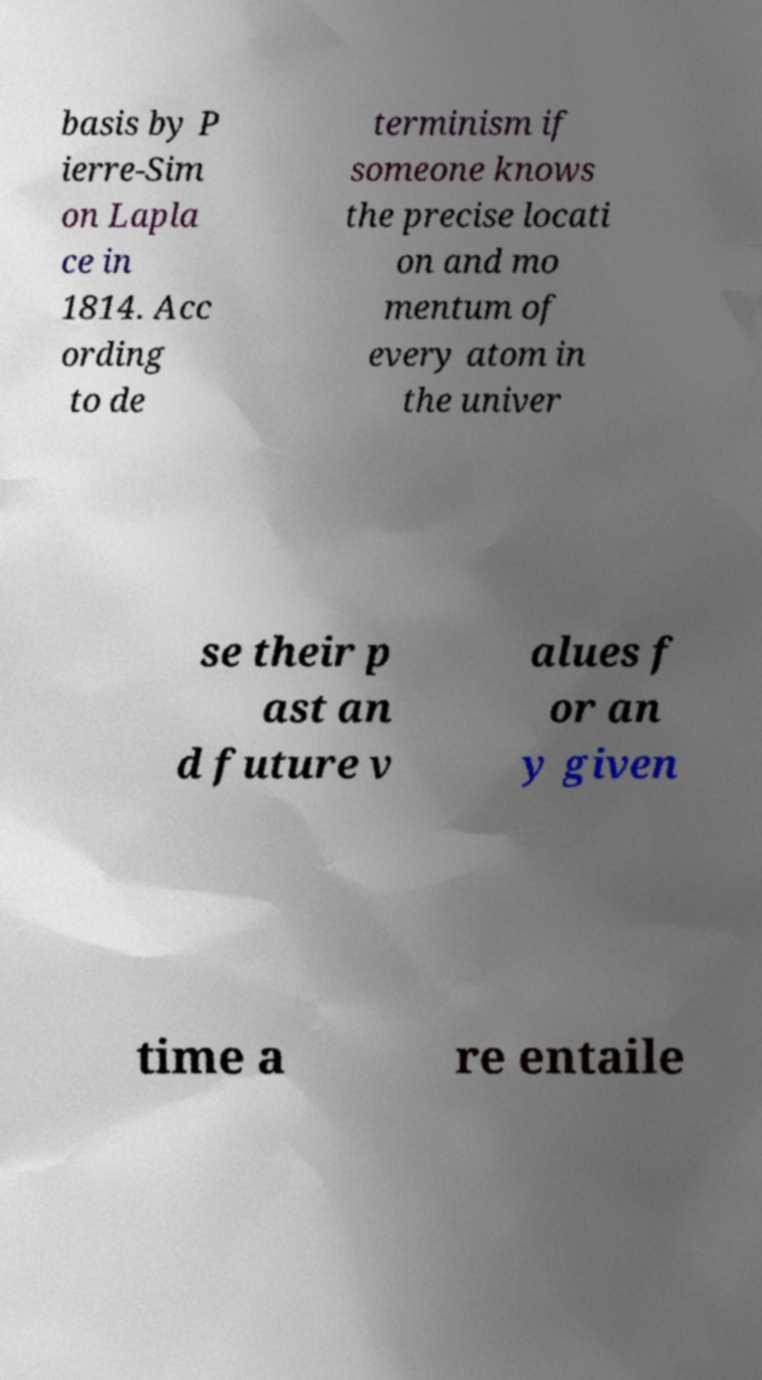Could you assist in decoding the text presented in this image and type it out clearly? basis by P ierre-Sim on Lapla ce in 1814. Acc ording to de terminism if someone knows the precise locati on and mo mentum of every atom in the univer se their p ast an d future v alues f or an y given time a re entaile 